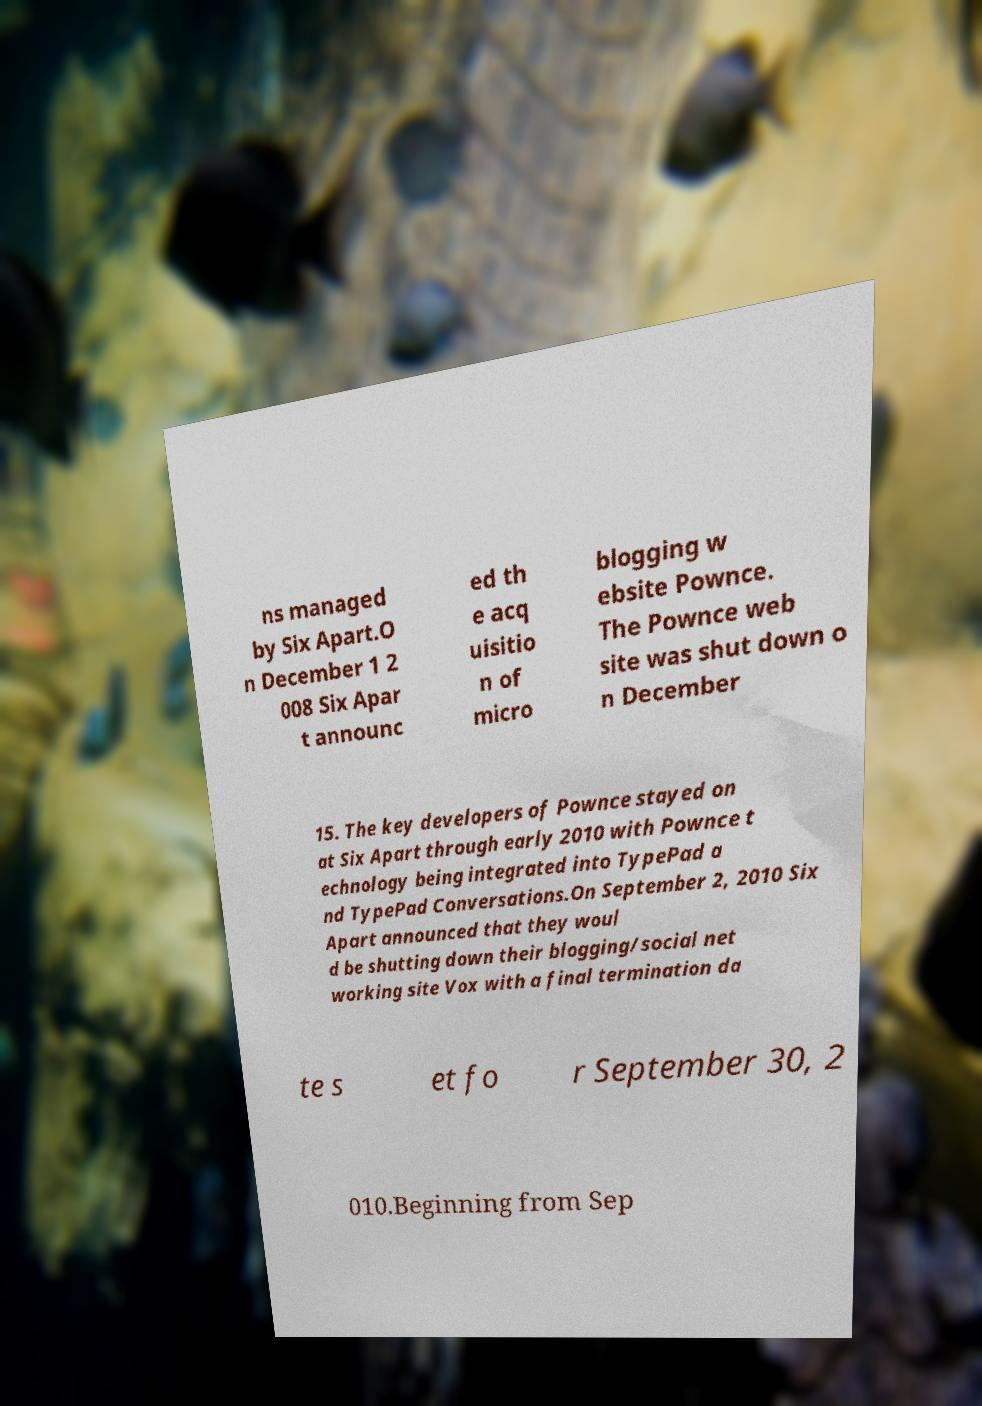What messages or text are displayed in this image? I need them in a readable, typed format. ns managed by Six Apart.O n December 1 2 008 Six Apar t announc ed th e acq uisitio n of micro blogging w ebsite Pownce. The Pownce web site was shut down o n December 15. The key developers of Pownce stayed on at Six Apart through early 2010 with Pownce t echnology being integrated into TypePad a nd TypePad Conversations.On September 2, 2010 Six Apart announced that they woul d be shutting down their blogging/social net working site Vox with a final termination da te s et fo r September 30, 2 010.Beginning from Sep 